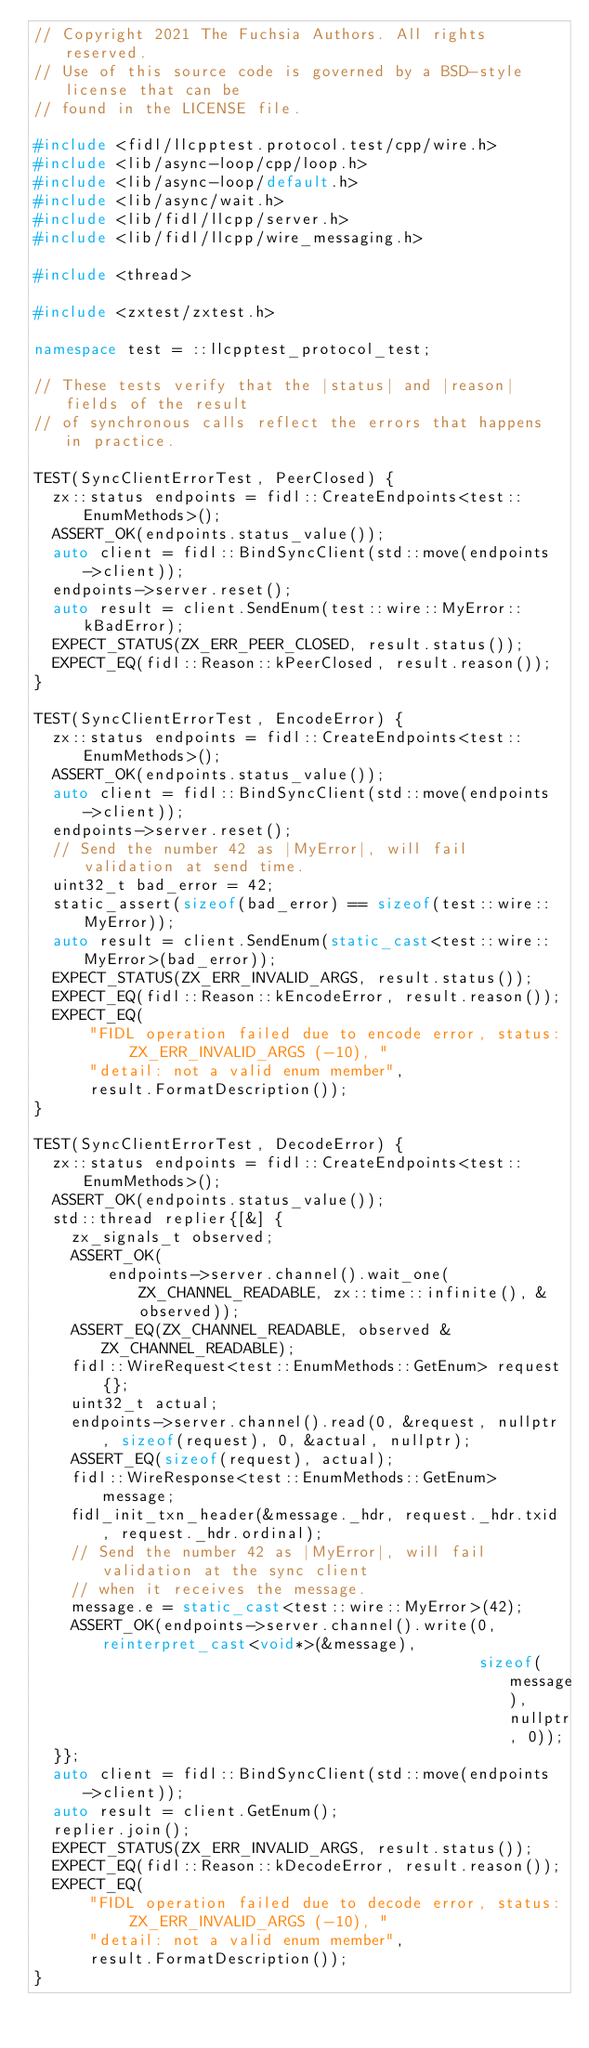Convert code to text. <code><loc_0><loc_0><loc_500><loc_500><_C++_>// Copyright 2021 The Fuchsia Authors. All rights reserved.
// Use of this source code is governed by a BSD-style license that can be
// found in the LICENSE file.

#include <fidl/llcpptest.protocol.test/cpp/wire.h>
#include <lib/async-loop/cpp/loop.h>
#include <lib/async-loop/default.h>
#include <lib/async/wait.h>
#include <lib/fidl/llcpp/server.h>
#include <lib/fidl/llcpp/wire_messaging.h>

#include <thread>

#include <zxtest/zxtest.h>

namespace test = ::llcpptest_protocol_test;

// These tests verify that the |status| and |reason| fields of the result
// of synchronous calls reflect the errors that happens in practice.

TEST(SyncClientErrorTest, PeerClosed) {
  zx::status endpoints = fidl::CreateEndpoints<test::EnumMethods>();
  ASSERT_OK(endpoints.status_value());
  auto client = fidl::BindSyncClient(std::move(endpoints->client));
  endpoints->server.reset();
  auto result = client.SendEnum(test::wire::MyError::kBadError);
  EXPECT_STATUS(ZX_ERR_PEER_CLOSED, result.status());
  EXPECT_EQ(fidl::Reason::kPeerClosed, result.reason());
}

TEST(SyncClientErrorTest, EncodeError) {
  zx::status endpoints = fidl::CreateEndpoints<test::EnumMethods>();
  ASSERT_OK(endpoints.status_value());
  auto client = fidl::BindSyncClient(std::move(endpoints->client));
  endpoints->server.reset();
  // Send the number 42 as |MyError|, will fail validation at send time.
  uint32_t bad_error = 42;
  static_assert(sizeof(bad_error) == sizeof(test::wire::MyError));
  auto result = client.SendEnum(static_cast<test::wire::MyError>(bad_error));
  EXPECT_STATUS(ZX_ERR_INVALID_ARGS, result.status());
  EXPECT_EQ(fidl::Reason::kEncodeError, result.reason());
  EXPECT_EQ(
      "FIDL operation failed due to encode error, status: ZX_ERR_INVALID_ARGS (-10), "
      "detail: not a valid enum member",
      result.FormatDescription());
}

TEST(SyncClientErrorTest, DecodeError) {
  zx::status endpoints = fidl::CreateEndpoints<test::EnumMethods>();
  ASSERT_OK(endpoints.status_value());
  std::thread replier{[&] {
    zx_signals_t observed;
    ASSERT_OK(
        endpoints->server.channel().wait_one(ZX_CHANNEL_READABLE, zx::time::infinite(), &observed));
    ASSERT_EQ(ZX_CHANNEL_READABLE, observed & ZX_CHANNEL_READABLE);
    fidl::WireRequest<test::EnumMethods::GetEnum> request{};
    uint32_t actual;
    endpoints->server.channel().read(0, &request, nullptr, sizeof(request), 0, &actual, nullptr);
    ASSERT_EQ(sizeof(request), actual);
    fidl::WireResponse<test::EnumMethods::GetEnum> message;
    fidl_init_txn_header(&message._hdr, request._hdr.txid, request._hdr.ordinal);
    // Send the number 42 as |MyError|, will fail validation at the sync client
    // when it receives the message.
    message.e = static_cast<test::wire::MyError>(42);
    ASSERT_OK(endpoints->server.channel().write(0, reinterpret_cast<void*>(&message),
                                                sizeof(message), nullptr, 0));
  }};
  auto client = fidl::BindSyncClient(std::move(endpoints->client));
  auto result = client.GetEnum();
  replier.join();
  EXPECT_STATUS(ZX_ERR_INVALID_ARGS, result.status());
  EXPECT_EQ(fidl::Reason::kDecodeError, result.reason());
  EXPECT_EQ(
      "FIDL operation failed due to decode error, status: ZX_ERR_INVALID_ARGS (-10), "
      "detail: not a valid enum member",
      result.FormatDescription());
}
</code> 